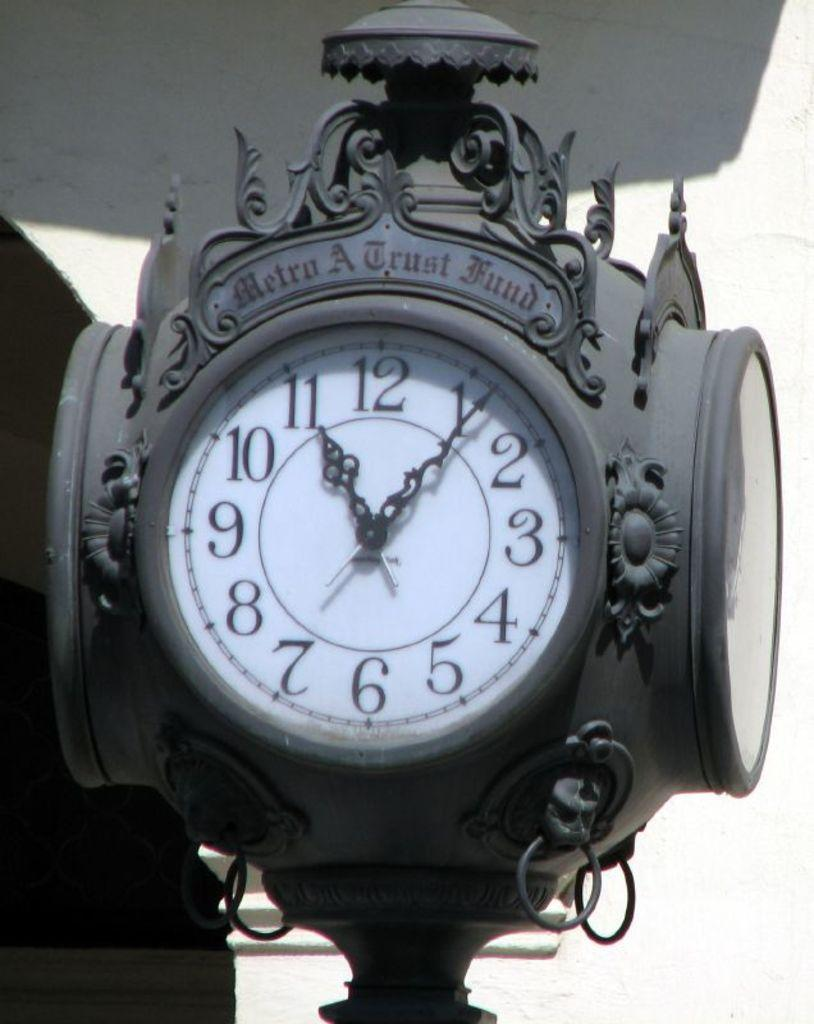<image>
Render a clear and concise summary of the photo. Above a clock face is the phrase, "metro a trust fund." 